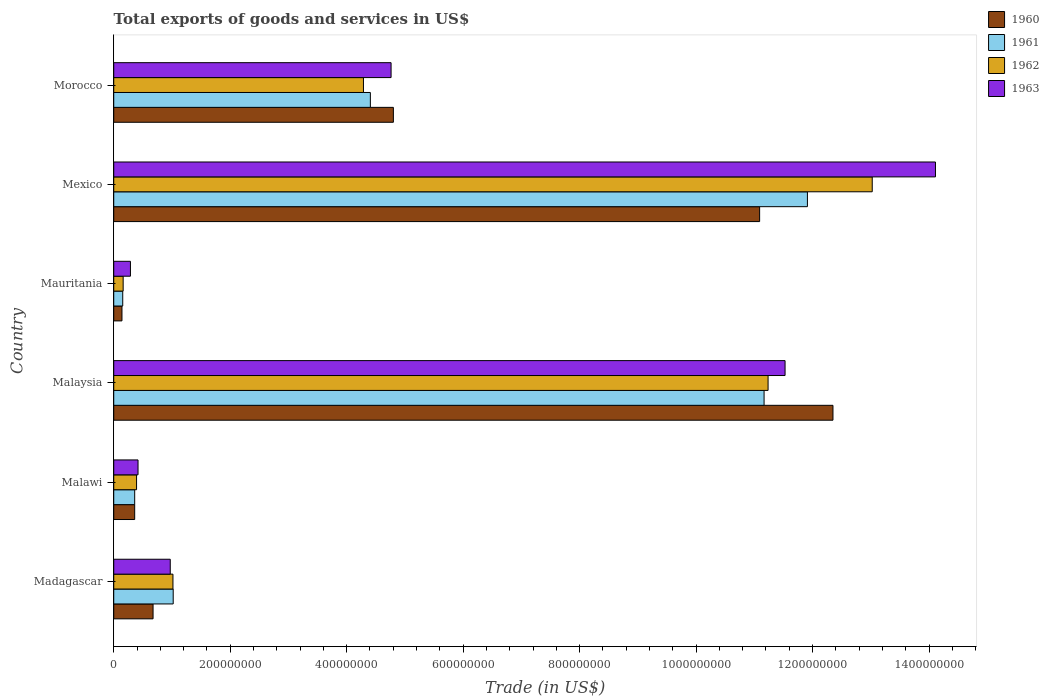How many groups of bars are there?
Make the answer very short. 6. Are the number of bars on each tick of the Y-axis equal?
Give a very brief answer. Yes. How many bars are there on the 1st tick from the top?
Provide a succinct answer. 4. How many bars are there on the 5th tick from the bottom?
Make the answer very short. 4. What is the label of the 3rd group of bars from the top?
Give a very brief answer. Mauritania. What is the total exports of goods and services in 1961 in Morocco?
Your answer should be very brief. 4.41e+08. Across all countries, what is the maximum total exports of goods and services in 1962?
Offer a very short reply. 1.30e+09. Across all countries, what is the minimum total exports of goods and services in 1962?
Ensure brevity in your answer.  1.62e+07. In which country was the total exports of goods and services in 1960 minimum?
Your answer should be compact. Mauritania. What is the total total exports of goods and services in 1963 in the graph?
Ensure brevity in your answer.  3.21e+09. What is the difference between the total exports of goods and services in 1960 in Malawi and that in Malaysia?
Offer a terse response. -1.20e+09. What is the difference between the total exports of goods and services in 1961 in Mauritania and the total exports of goods and services in 1960 in Mexico?
Give a very brief answer. -1.09e+09. What is the average total exports of goods and services in 1962 per country?
Keep it short and to the point. 5.02e+08. What is the difference between the total exports of goods and services in 1963 and total exports of goods and services in 1960 in Madagascar?
Your answer should be compact. 2.95e+07. What is the ratio of the total exports of goods and services in 1961 in Madagascar to that in Mauritania?
Provide a succinct answer. 6.61. Is the total exports of goods and services in 1963 in Malaysia less than that in Morocco?
Offer a terse response. No. Is the difference between the total exports of goods and services in 1963 in Malaysia and Mauritania greater than the difference between the total exports of goods and services in 1960 in Malaysia and Mauritania?
Provide a succinct answer. No. What is the difference between the highest and the second highest total exports of goods and services in 1962?
Keep it short and to the point. 1.79e+08. What is the difference between the highest and the lowest total exports of goods and services in 1960?
Your response must be concise. 1.22e+09. In how many countries, is the total exports of goods and services in 1960 greater than the average total exports of goods and services in 1960 taken over all countries?
Your answer should be very brief. 2. Is the sum of the total exports of goods and services in 1960 in Malawi and Mauritania greater than the maximum total exports of goods and services in 1962 across all countries?
Provide a succinct answer. No. What does the 3rd bar from the top in Morocco represents?
Keep it short and to the point. 1961. What does the 4th bar from the bottom in Malawi represents?
Offer a terse response. 1963. How many countries are there in the graph?
Offer a terse response. 6. Does the graph contain any zero values?
Your answer should be very brief. No. Does the graph contain grids?
Your answer should be compact. No. How many legend labels are there?
Offer a very short reply. 4. What is the title of the graph?
Provide a short and direct response. Total exports of goods and services in US$. What is the label or title of the X-axis?
Your response must be concise. Trade (in US$). What is the label or title of the Y-axis?
Offer a very short reply. Country. What is the Trade (in US$) of 1960 in Madagascar?
Your response must be concise. 6.75e+07. What is the Trade (in US$) of 1961 in Madagascar?
Offer a terse response. 1.02e+08. What is the Trade (in US$) in 1962 in Madagascar?
Your answer should be compact. 1.02e+08. What is the Trade (in US$) in 1963 in Madagascar?
Give a very brief answer. 9.70e+07. What is the Trade (in US$) of 1960 in Malawi?
Ensure brevity in your answer.  3.60e+07. What is the Trade (in US$) in 1961 in Malawi?
Your answer should be compact. 3.60e+07. What is the Trade (in US$) of 1962 in Malawi?
Your answer should be very brief. 3.92e+07. What is the Trade (in US$) of 1963 in Malawi?
Your response must be concise. 4.17e+07. What is the Trade (in US$) of 1960 in Malaysia?
Keep it short and to the point. 1.24e+09. What is the Trade (in US$) in 1961 in Malaysia?
Offer a very short reply. 1.12e+09. What is the Trade (in US$) of 1962 in Malaysia?
Your answer should be very brief. 1.12e+09. What is the Trade (in US$) of 1963 in Malaysia?
Provide a succinct answer. 1.15e+09. What is the Trade (in US$) in 1960 in Mauritania?
Ensure brevity in your answer.  1.41e+07. What is the Trade (in US$) in 1961 in Mauritania?
Ensure brevity in your answer.  1.54e+07. What is the Trade (in US$) of 1962 in Mauritania?
Your response must be concise. 1.62e+07. What is the Trade (in US$) of 1963 in Mauritania?
Offer a terse response. 2.87e+07. What is the Trade (in US$) in 1960 in Mexico?
Keep it short and to the point. 1.11e+09. What is the Trade (in US$) in 1961 in Mexico?
Your answer should be very brief. 1.19e+09. What is the Trade (in US$) of 1962 in Mexico?
Offer a terse response. 1.30e+09. What is the Trade (in US$) of 1963 in Mexico?
Keep it short and to the point. 1.41e+09. What is the Trade (in US$) in 1960 in Morocco?
Make the answer very short. 4.80e+08. What is the Trade (in US$) in 1961 in Morocco?
Your response must be concise. 4.41e+08. What is the Trade (in US$) in 1962 in Morocco?
Your answer should be very brief. 4.29e+08. What is the Trade (in US$) of 1963 in Morocco?
Your answer should be very brief. 4.76e+08. Across all countries, what is the maximum Trade (in US$) of 1960?
Your response must be concise. 1.24e+09. Across all countries, what is the maximum Trade (in US$) in 1961?
Provide a short and direct response. 1.19e+09. Across all countries, what is the maximum Trade (in US$) in 1962?
Give a very brief answer. 1.30e+09. Across all countries, what is the maximum Trade (in US$) in 1963?
Provide a succinct answer. 1.41e+09. Across all countries, what is the minimum Trade (in US$) of 1960?
Ensure brevity in your answer.  1.41e+07. Across all countries, what is the minimum Trade (in US$) in 1961?
Offer a terse response. 1.54e+07. Across all countries, what is the minimum Trade (in US$) of 1962?
Offer a terse response. 1.62e+07. Across all countries, what is the minimum Trade (in US$) in 1963?
Provide a short and direct response. 2.87e+07. What is the total Trade (in US$) in 1960 in the graph?
Offer a very short reply. 2.94e+09. What is the total Trade (in US$) in 1961 in the graph?
Provide a succinct answer. 2.90e+09. What is the total Trade (in US$) in 1962 in the graph?
Make the answer very short. 3.01e+09. What is the total Trade (in US$) in 1963 in the graph?
Make the answer very short. 3.21e+09. What is the difference between the Trade (in US$) of 1960 in Madagascar and that in Malawi?
Offer a very short reply. 3.15e+07. What is the difference between the Trade (in US$) in 1961 in Madagascar and that in Malawi?
Provide a succinct answer. 6.61e+07. What is the difference between the Trade (in US$) of 1962 in Madagascar and that in Malawi?
Your answer should be compact. 6.25e+07. What is the difference between the Trade (in US$) of 1963 in Madagascar and that in Malawi?
Your answer should be very brief. 5.53e+07. What is the difference between the Trade (in US$) of 1960 in Madagascar and that in Malaysia?
Offer a terse response. -1.17e+09. What is the difference between the Trade (in US$) in 1961 in Madagascar and that in Malaysia?
Make the answer very short. -1.01e+09. What is the difference between the Trade (in US$) of 1962 in Madagascar and that in Malaysia?
Your response must be concise. -1.02e+09. What is the difference between the Trade (in US$) in 1963 in Madagascar and that in Malaysia?
Give a very brief answer. -1.06e+09. What is the difference between the Trade (in US$) in 1960 in Madagascar and that in Mauritania?
Make the answer very short. 5.34e+07. What is the difference between the Trade (in US$) in 1961 in Madagascar and that in Mauritania?
Provide a short and direct response. 8.67e+07. What is the difference between the Trade (in US$) of 1962 in Madagascar and that in Mauritania?
Offer a very short reply. 8.55e+07. What is the difference between the Trade (in US$) of 1963 in Madagascar and that in Mauritania?
Make the answer very short. 6.84e+07. What is the difference between the Trade (in US$) in 1960 in Madagascar and that in Mexico?
Provide a short and direct response. -1.04e+09. What is the difference between the Trade (in US$) in 1961 in Madagascar and that in Mexico?
Provide a short and direct response. -1.09e+09. What is the difference between the Trade (in US$) in 1962 in Madagascar and that in Mexico?
Provide a short and direct response. -1.20e+09. What is the difference between the Trade (in US$) in 1963 in Madagascar and that in Mexico?
Provide a short and direct response. -1.31e+09. What is the difference between the Trade (in US$) of 1960 in Madagascar and that in Morocco?
Make the answer very short. -4.13e+08. What is the difference between the Trade (in US$) of 1961 in Madagascar and that in Morocco?
Offer a very short reply. -3.39e+08. What is the difference between the Trade (in US$) of 1962 in Madagascar and that in Morocco?
Provide a short and direct response. -3.27e+08. What is the difference between the Trade (in US$) in 1963 in Madagascar and that in Morocco?
Provide a succinct answer. -3.79e+08. What is the difference between the Trade (in US$) of 1960 in Malawi and that in Malaysia?
Offer a terse response. -1.20e+09. What is the difference between the Trade (in US$) in 1961 in Malawi and that in Malaysia?
Offer a terse response. -1.08e+09. What is the difference between the Trade (in US$) of 1962 in Malawi and that in Malaysia?
Provide a short and direct response. -1.08e+09. What is the difference between the Trade (in US$) of 1963 in Malawi and that in Malaysia?
Your response must be concise. -1.11e+09. What is the difference between the Trade (in US$) in 1960 in Malawi and that in Mauritania?
Your response must be concise. 2.18e+07. What is the difference between the Trade (in US$) of 1961 in Malawi and that in Mauritania?
Provide a short and direct response. 2.05e+07. What is the difference between the Trade (in US$) of 1962 in Malawi and that in Mauritania?
Your response must be concise. 2.30e+07. What is the difference between the Trade (in US$) in 1963 in Malawi and that in Mauritania?
Your answer should be compact. 1.30e+07. What is the difference between the Trade (in US$) of 1960 in Malawi and that in Mexico?
Your answer should be very brief. -1.07e+09. What is the difference between the Trade (in US$) of 1961 in Malawi and that in Mexico?
Offer a terse response. -1.16e+09. What is the difference between the Trade (in US$) in 1962 in Malawi and that in Mexico?
Ensure brevity in your answer.  -1.26e+09. What is the difference between the Trade (in US$) in 1963 in Malawi and that in Mexico?
Keep it short and to the point. -1.37e+09. What is the difference between the Trade (in US$) in 1960 in Malawi and that in Morocco?
Your response must be concise. -4.44e+08. What is the difference between the Trade (in US$) of 1961 in Malawi and that in Morocco?
Keep it short and to the point. -4.05e+08. What is the difference between the Trade (in US$) of 1962 in Malawi and that in Morocco?
Provide a succinct answer. -3.90e+08. What is the difference between the Trade (in US$) in 1963 in Malawi and that in Morocco?
Provide a succinct answer. -4.35e+08. What is the difference between the Trade (in US$) in 1960 in Malaysia and that in Mauritania?
Offer a very short reply. 1.22e+09. What is the difference between the Trade (in US$) in 1961 in Malaysia and that in Mauritania?
Your answer should be very brief. 1.10e+09. What is the difference between the Trade (in US$) in 1962 in Malaysia and that in Mauritania?
Provide a short and direct response. 1.11e+09. What is the difference between the Trade (in US$) in 1963 in Malaysia and that in Mauritania?
Your response must be concise. 1.12e+09. What is the difference between the Trade (in US$) of 1960 in Malaysia and that in Mexico?
Make the answer very short. 1.26e+08. What is the difference between the Trade (in US$) of 1961 in Malaysia and that in Mexico?
Offer a terse response. -7.44e+07. What is the difference between the Trade (in US$) in 1962 in Malaysia and that in Mexico?
Make the answer very short. -1.79e+08. What is the difference between the Trade (in US$) in 1963 in Malaysia and that in Mexico?
Your answer should be compact. -2.58e+08. What is the difference between the Trade (in US$) in 1960 in Malaysia and that in Morocco?
Keep it short and to the point. 7.55e+08. What is the difference between the Trade (in US$) in 1961 in Malaysia and that in Morocco?
Keep it short and to the point. 6.76e+08. What is the difference between the Trade (in US$) of 1962 in Malaysia and that in Morocco?
Keep it short and to the point. 6.95e+08. What is the difference between the Trade (in US$) of 1963 in Malaysia and that in Morocco?
Ensure brevity in your answer.  6.77e+08. What is the difference between the Trade (in US$) of 1960 in Mauritania and that in Mexico?
Your response must be concise. -1.09e+09. What is the difference between the Trade (in US$) in 1961 in Mauritania and that in Mexico?
Your answer should be very brief. -1.18e+09. What is the difference between the Trade (in US$) of 1962 in Mauritania and that in Mexico?
Your response must be concise. -1.29e+09. What is the difference between the Trade (in US$) in 1963 in Mauritania and that in Mexico?
Offer a very short reply. -1.38e+09. What is the difference between the Trade (in US$) in 1960 in Mauritania and that in Morocco?
Give a very brief answer. -4.66e+08. What is the difference between the Trade (in US$) in 1961 in Mauritania and that in Morocco?
Your response must be concise. -4.25e+08. What is the difference between the Trade (in US$) of 1962 in Mauritania and that in Morocco?
Your answer should be compact. -4.13e+08. What is the difference between the Trade (in US$) of 1963 in Mauritania and that in Morocco?
Your answer should be compact. -4.48e+08. What is the difference between the Trade (in US$) in 1960 in Mexico and that in Morocco?
Your answer should be compact. 6.29e+08. What is the difference between the Trade (in US$) in 1961 in Mexico and that in Morocco?
Keep it short and to the point. 7.51e+08. What is the difference between the Trade (in US$) in 1962 in Mexico and that in Morocco?
Offer a terse response. 8.74e+08. What is the difference between the Trade (in US$) of 1963 in Mexico and that in Morocco?
Offer a terse response. 9.35e+08. What is the difference between the Trade (in US$) in 1960 in Madagascar and the Trade (in US$) in 1961 in Malawi?
Your response must be concise. 3.15e+07. What is the difference between the Trade (in US$) of 1960 in Madagascar and the Trade (in US$) of 1962 in Malawi?
Your answer should be very brief. 2.83e+07. What is the difference between the Trade (in US$) in 1960 in Madagascar and the Trade (in US$) in 1963 in Malawi?
Your response must be concise. 2.58e+07. What is the difference between the Trade (in US$) of 1961 in Madagascar and the Trade (in US$) of 1962 in Malawi?
Offer a very short reply. 6.29e+07. What is the difference between the Trade (in US$) of 1961 in Madagascar and the Trade (in US$) of 1963 in Malawi?
Keep it short and to the point. 6.04e+07. What is the difference between the Trade (in US$) in 1962 in Madagascar and the Trade (in US$) in 1963 in Malawi?
Provide a succinct answer. 6.00e+07. What is the difference between the Trade (in US$) of 1960 in Madagascar and the Trade (in US$) of 1961 in Malaysia?
Make the answer very short. -1.05e+09. What is the difference between the Trade (in US$) of 1960 in Madagascar and the Trade (in US$) of 1962 in Malaysia?
Your response must be concise. -1.06e+09. What is the difference between the Trade (in US$) in 1960 in Madagascar and the Trade (in US$) in 1963 in Malaysia?
Your answer should be compact. -1.09e+09. What is the difference between the Trade (in US$) of 1961 in Madagascar and the Trade (in US$) of 1962 in Malaysia?
Offer a very short reply. -1.02e+09. What is the difference between the Trade (in US$) in 1961 in Madagascar and the Trade (in US$) in 1963 in Malaysia?
Your response must be concise. -1.05e+09. What is the difference between the Trade (in US$) of 1962 in Madagascar and the Trade (in US$) of 1963 in Malaysia?
Offer a very short reply. -1.05e+09. What is the difference between the Trade (in US$) in 1960 in Madagascar and the Trade (in US$) in 1961 in Mauritania?
Ensure brevity in your answer.  5.21e+07. What is the difference between the Trade (in US$) in 1960 in Madagascar and the Trade (in US$) in 1962 in Mauritania?
Keep it short and to the point. 5.14e+07. What is the difference between the Trade (in US$) in 1960 in Madagascar and the Trade (in US$) in 1963 in Mauritania?
Ensure brevity in your answer.  3.88e+07. What is the difference between the Trade (in US$) in 1961 in Madagascar and the Trade (in US$) in 1962 in Mauritania?
Make the answer very short. 8.60e+07. What is the difference between the Trade (in US$) in 1961 in Madagascar and the Trade (in US$) in 1963 in Mauritania?
Ensure brevity in your answer.  7.34e+07. What is the difference between the Trade (in US$) in 1962 in Madagascar and the Trade (in US$) in 1963 in Mauritania?
Keep it short and to the point. 7.30e+07. What is the difference between the Trade (in US$) in 1960 in Madagascar and the Trade (in US$) in 1961 in Mexico?
Offer a very short reply. -1.12e+09. What is the difference between the Trade (in US$) of 1960 in Madagascar and the Trade (in US$) of 1962 in Mexico?
Provide a short and direct response. -1.23e+09. What is the difference between the Trade (in US$) of 1960 in Madagascar and the Trade (in US$) of 1963 in Mexico?
Give a very brief answer. -1.34e+09. What is the difference between the Trade (in US$) of 1961 in Madagascar and the Trade (in US$) of 1962 in Mexico?
Ensure brevity in your answer.  -1.20e+09. What is the difference between the Trade (in US$) in 1961 in Madagascar and the Trade (in US$) in 1963 in Mexico?
Provide a succinct answer. -1.31e+09. What is the difference between the Trade (in US$) of 1962 in Madagascar and the Trade (in US$) of 1963 in Mexico?
Your answer should be very brief. -1.31e+09. What is the difference between the Trade (in US$) in 1960 in Madagascar and the Trade (in US$) in 1961 in Morocco?
Your response must be concise. -3.73e+08. What is the difference between the Trade (in US$) of 1960 in Madagascar and the Trade (in US$) of 1962 in Morocco?
Offer a very short reply. -3.61e+08. What is the difference between the Trade (in US$) of 1960 in Madagascar and the Trade (in US$) of 1963 in Morocco?
Provide a succinct answer. -4.09e+08. What is the difference between the Trade (in US$) of 1961 in Madagascar and the Trade (in US$) of 1962 in Morocco?
Make the answer very short. -3.27e+08. What is the difference between the Trade (in US$) of 1961 in Madagascar and the Trade (in US$) of 1963 in Morocco?
Provide a succinct answer. -3.74e+08. What is the difference between the Trade (in US$) of 1962 in Madagascar and the Trade (in US$) of 1963 in Morocco?
Offer a terse response. -3.75e+08. What is the difference between the Trade (in US$) of 1960 in Malawi and the Trade (in US$) of 1961 in Malaysia?
Your response must be concise. -1.08e+09. What is the difference between the Trade (in US$) in 1960 in Malawi and the Trade (in US$) in 1962 in Malaysia?
Your answer should be compact. -1.09e+09. What is the difference between the Trade (in US$) of 1960 in Malawi and the Trade (in US$) of 1963 in Malaysia?
Ensure brevity in your answer.  -1.12e+09. What is the difference between the Trade (in US$) in 1961 in Malawi and the Trade (in US$) in 1962 in Malaysia?
Provide a succinct answer. -1.09e+09. What is the difference between the Trade (in US$) in 1961 in Malawi and the Trade (in US$) in 1963 in Malaysia?
Your response must be concise. -1.12e+09. What is the difference between the Trade (in US$) in 1962 in Malawi and the Trade (in US$) in 1963 in Malaysia?
Your answer should be compact. -1.11e+09. What is the difference between the Trade (in US$) of 1960 in Malawi and the Trade (in US$) of 1961 in Mauritania?
Ensure brevity in your answer.  2.05e+07. What is the difference between the Trade (in US$) of 1960 in Malawi and the Trade (in US$) of 1962 in Mauritania?
Ensure brevity in your answer.  1.98e+07. What is the difference between the Trade (in US$) of 1960 in Malawi and the Trade (in US$) of 1963 in Mauritania?
Make the answer very short. 7.31e+06. What is the difference between the Trade (in US$) of 1961 in Malawi and the Trade (in US$) of 1962 in Mauritania?
Offer a very short reply. 1.98e+07. What is the difference between the Trade (in US$) in 1961 in Malawi and the Trade (in US$) in 1963 in Mauritania?
Your response must be concise. 7.31e+06. What is the difference between the Trade (in US$) of 1962 in Malawi and the Trade (in US$) of 1963 in Mauritania?
Keep it short and to the point. 1.05e+07. What is the difference between the Trade (in US$) of 1960 in Malawi and the Trade (in US$) of 1961 in Mexico?
Your answer should be very brief. -1.16e+09. What is the difference between the Trade (in US$) in 1960 in Malawi and the Trade (in US$) in 1962 in Mexico?
Provide a succinct answer. -1.27e+09. What is the difference between the Trade (in US$) of 1960 in Malawi and the Trade (in US$) of 1963 in Mexico?
Your response must be concise. -1.38e+09. What is the difference between the Trade (in US$) in 1961 in Malawi and the Trade (in US$) in 1962 in Mexico?
Provide a short and direct response. -1.27e+09. What is the difference between the Trade (in US$) in 1961 in Malawi and the Trade (in US$) in 1963 in Mexico?
Your response must be concise. -1.38e+09. What is the difference between the Trade (in US$) of 1962 in Malawi and the Trade (in US$) of 1963 in Mexico?
Make the answer very short. -1.37e+09. What is the difference between the Trade (in US$) of 1960 in Malawi and the Trade (in US$) of 1961 in Morocco?
Your answer should be very brief. -4.05e+08. What is the difference between the Trade (in US$) of 1960 in Malawi and the Trade (in US$) of 1962 in Morocco?
Offer a terse response. -3.93e+08. What is the difference between the Trade (in US$) of 1960 in Malawi and the Trade (in US$) of 1963 in Morocco?
Your answer should be very brief. -4.40e+08. What is the difference between the Trade (in US$) in 1961 in Malawi and the Trade (in US$) in 1962 in Morocco?
Make the answer very short. -3.93e+08. What is the difference between the Trade (in US$) in 1961 in Malawi and the Trade (in US$) in 1963 in Morocco?
Your response must be concise. -4.40e+08. What is the difference between the Trade (in US$) of 1962 in Malawi and the Trade (in US$) of 1963 in Morocco?
Keep it short and to the point. -4.37e+08. What is the difference between the Trade (in US$) of 1960 in Malaysia and the Trade (in US$) of 1961 in Mauritania?
Your answer should be very brief. 1.22e+09. What is the difference between the Trade (in US$) of 1960 in Malaysia and the Trade (in US$) of 1962 in Mauritania?
Offer a terse response. 1.22e+09. What is the difference between the Trade (in US$) in 1960 in Malaysia and the Trade (in US$) in 1963 in Mauritania?
Make the answer very short. 1.21e+09. What is the difference between the Trade (in US$) of 1961 in Malaysia and the Trade (in US$) of 1962 in Mauritania?
Ensure brevity in your answer.  1.10e+09. What is the difference between the Trade (in US$) of 1961 in Malaysia and the Trade (in US$) of 1963 in Mauritania?
Provide a succinct answer. 1.09e+09. What is the difference between the Trade (in US$) of 1962 in Malaysia and the Trade (in US$) of 1963 in Mauritania?
Keep it short and to the point. 1.09e+09. What is the difference between the Trade (in US$) of 1960 in Malaysia and the Trade (in US$) of 1961 in Mexico?
Offer a very short reply. 4.39e+07. What is the difference between the Trade (in US$) of 1960 in Malaysia and the Trade (in US$) of 1962 in Mexico?
Your answer should be compact. -6.74e+07. What is the difference between the Trade (in US$) in 1960 in Malaysia and the Trade (in US$) in 1963 in Mexico?
Give a very brief answer. -1.76e+08. What is the difference between the Trade (in US$) of 1961 in Malaysia and the Trade (in US$) of 1962 in Mexico?
Your response must be concise. -1.86e+08. What is the difference between the Trade (in US$) in 1961 in Malaysia and the Trade (in US$) in 1963 in Mexico?
Provide a succinct answer. -2.94e+08. What is the difference between the Trade (in US$) in 1962 in Malaysia and the Trade (in US$) in 1963 in Mexico?
Keep it short and to the point. -2.87e+08. What is the difference between the Trade (in US$) of 1960 in Malaysia and the Trade (in US$) of 1961 in Morocco?
Offer a terse response. 7.94e+08. What is the difference between the Trade (in US$) in 1960 in Malaysia and the Trade (in US$) in 1962 in Morocco?
Keep it short and to the point. 8.06e+08. What is the difference between the Trade (in US$) of 1960 in Malaysia and the Trade (in US$) of 1963 in Morocco?
Make the answer very short. 7.59e+08. What is the difference between the Trade (in US$) of 1961 in Malaysia and the Trade (in US$) of 1962 in Morocco?
Ensure brevity in your answer.  6.88e+08. What is the difference between the Trade (in US$) of 1961 in Malaysia and the Trade (in US$) of 1963 in Morocco?
Give a very brief answer. 6.41e+08. What is the difference between the Trade (in US$) in 1962 in Malaysia and the Trade (in US$) in 1963 in Morocco?
Ensure brevity in your answer.  6.47e+08. What is the difference between the Trade (in US$) in 1960 in Mauritania and the Trade (in US$) in 1961 in Mexico?
Provide a short and direct response. -1.18e+09. What is the difference between the Trade (in US$) of 1960 in Mauritania and the Trade (in US$) of 1962 in Mexico?
Offer a very short reply. -1.29e+09. What is the difference between the Trade (in US$) of 1960 in Mauritania and the Trade (in US$) of 1963 in Mexico?
Ensure brevity in your answer.  -1.40e+09. What is the difference between the Trade (in US$) of 1961 in Mauritania and the Trade (in US$) of 1962 in Mexico?
Offer a terse response. -1.29e+09. What is the difference between the Trade (in US$) of 1961 in Mauritania and the Trade (in US$) of 1963 in Mexico?
Your answer should be compact. -1.40e+09. What is the difference between the Trade (in US$) of 1962 in Mauritania and the Trade (in US$) of 1963 in Mexico?
Offer a terse response. -1.39e+09. What is the difference between the Trade (in US$) of 1960 in Mauritania and the Trade (in US$) of 1961 in Morocco?
Ensure brevity in your answer.  -4.27e+08. What is the difference between the Trade (in US$) in 1960 in Mauritania and the Trade (in US$) in 1962 in Morocco?
Provide a succinct answer. -4.15e+08. What is the difference between the Trade (in US$) in 1960 in Mauritania and the Trade (in US$) in 1963 in Morocco?
Keep it short and to the point. -4.62e+08. What is the difference between the Trade (in US$) in 1961 in Mauritania and the Trade (in US$) in 1962 in Morocco?
Provide a short and direct response. -4.13e+08. What is the difference between the Trade (in US$) of 1961 in Mauritania and the Trade (in US$) of 1963 in Morocco?
Give a very brief answer. -4.61e+08. What is the difference between the Trade (in US$) in 1962 in Mauritania and the Trade (in US$) in 1963 in Morocco?
Provide a short and direct response. -4.60e+08. What is the difference between the Trade (in US$) of 1960 in Mexico and the Trade (in US$) of 1961 in Morocco?
Keep it short and to the point. 6.68e+08. What is the difference between the Trade (in US$) of 1960 in Mexico and the Trade (in US$) of 1962 in Morocco?
Your response must be concise. 6.80e+08. What is the difference between the Trade (in US$) in 1960 in Mexico and the Trade (in US$) in 1963 in Morocco?
Offer a very short reply. 6.33e+08. What is the difference between the Trade (in US$) in 1961 in Mexico and the Trade (in US$) in 1962 in Morocco?
Offer a terse response. 7.62e+08. What is the difference between the Trade (in US$) in 1961 in Mexico and the Trade (in US$) in 1963 in Morocco?
Ensure brevity in your answer.  7.15e+08. What is the difference between the Trade (in US$) of 1962 in Mexico and the Trade (in US$) of 1963 in Morocco?
Give a very brief answer. 8.26e+08. What is the average Trade (in US$) of 1960 per country?
Make the answer very short. 4.90e+08. What is the average Trade (in US$) of 1961 per country?
Your answer should be very brief. 4.84e+08. What is the average Trade (in US$) in 1962 per country?
Give a very brief answer. 5.02e+08. What is the average Trade (in US$) in 1963 per country?
Your response must be concise. 5.35e+08. What is the difference between the Trade (in US$) in 1960 and Trade (in US$) in 1961 in Madagascar?
Provide a short and direct response. -3.46e+07. What is the difference between the Trade (in US$) of 1960 and Trade (in US$) of 1962 in Madagascar?
Offer a very short reply. -3.42e+07. What is the difference between the Trade (in US$) in 1960 and Trade (in US$) in 1963 in Madagascar?
Ensure brevity in your answer.  -2.95e+07. What is the difference between the Trade (in US$) in 1961 and Trade (in US$) in 1962 in Madagascar?
Provide a short and direct response. 4.22e+05. What is the difference between the Trade (in US$) of 1961 and Trade (in US$) of 1963 in Madagascar?
Offer a very short reply. 5.06e+06. What is the difference between the Trade (in US$) of 1962 and Trade (in US$) of 1963 in Madagascar?
Your answer should be very brief. 4.64e+06. What is the difference between the Trade (in US$) of 1960 and Trade (in US$) of 1962 in Malawi?
Make the answer very short. -3.22e+06. What is the difference between the Trade (in US$) of 1960 and Trade (in US$) of 1963 in Malawi?
Offer a terse response. -5.74e+06. What is the difference between the Trade (in US$) in 1961 and Trade (in US$) in 1962 in Malawi?
Your answer should be very brief. -3.22e+06. What is the difference between the Trade (in US$) in 1961 and Trade (in US$) in 1963 in Malawi?
Make the answer very short. -5.74e+06. What is the difference between the Trade (in US$) of 1962 and Trade (in US$) of 1963 in Malawi?
Your response must be concise. -2.52e+06. What is the difference between the Trade (in US$) in 1960 and Trade (in US$) in 1961 in Malaysia?
Keep it short and to the point. 1.18e+08. What is the difference between the Trade (in US$) of 1960 and Trade (in US$) of 1962 in Malaysia?
Offer a terse response. 1.11e+08. What is the difference between the Trade (in US$) of 1960 and Trade (in US$) of 1963 in Malaysia?
Offer a terse response. 8.23e+07. What is the difference between the Trade (in US$) in 1961 and Trade (in US$) in 1962 in Malaysia?
Your response must be concise. -6.88e+06. What is the difference between the Trade (in US$) in 1961 and Trade (in US$) in 1963 in Malaysia?
Provide a short and direct response. -3.60e+07. What is the difference between the Trade (in US$) of 1962 and Trade (in US$) of 1963 in Malaysia?
Make the answer very short. -2.92e+07. What is the difference between the Trade (in US$) of 1960 and Trade (in US$) of 1961 in Mauritania?
Offer a very short reply. -1.31e+06. What is the difference between the Trade (in US$) in 1960 and Trade (in US$) in 1962 in Mauritania?
Your response must be concise. -2.02e+06. What is the difference between the Trade (in US$) in 1960 and Trade (in US$) in 1963 in Mauritania?
Give a very brief answer. -1.45e+07. What is the difference between the Trade (in US$) of 1961 and Trade (in US$) of 1962 in Mauritania?
Offer a terse response. -7.07e+05. What is the difference between the Trade (in US$) in 1961 and Trade (in US$) in 1963 in Mauritania?
Provide a short and direct response. -1.32e+07. What is the difference between the Trade (in US$) of 1962 and Trade (in US$) of 1963 in Mauritania?
Make the answer very short. -1.25e+07. What is the difference between the Trade (in US$) of 1960 and Trade (in US$) of 1961 in Mexico?
Make the answer very short. -8.21e+07. What is the difference between the Trade (in US$) in 1960 and Trade (in US$) in 1962 in Mexico?
Keep it short and to the point. -1.93e+08. What is the difference between the Trade (in US$) in 1960 and Trade (in US$) in 1963 in Mexico?
Provide a succinct answer. -3.02e+08. What is the difference between the Trade (in US$) in 1961 and Trade (in US$) in 1962 in Mexico?
Offer a very short reply. -1.11e+08. What is the difference between the Trade (in US$) of 1961 and Trade (in US$) of 1963 in Mexico?
Your answer should be very brief. -2.20e+08. What is the difference between the Trade (in US$) in 1962 and Trade (in US$) in 1963 in Mexico?
Your answer should be very brief. -1.09e+08. What is the difference between the Trade (in US$) in 1960 and Trade (in US$) in 1961 in Morocco?
Provide a short and direct response. 3.95e+07. What is the difference between the Trade (in US$) in 1960 and Trade (in US$) in 1962 in Morocco?
Ensure brevity in your answer.  5.14e+07. What is the difference between the Trade (in US$) in 1960 and Trade (in US$) in 1963 in Morocco?
Provide a succinct answer. 3.95e+06. What is the difference between the Trade (in US$) in 1961 and Trade (in US$) in 1962 in Morocco?
Offer a terse response. 1.19e+07. What is the difference between the Trade (in US$) in 1961 and Trade (in US$) in 1963 in Morocco?
Make the answer very short. -3.56e+07. What is the difference between the Trade (in US$) of 1962 and Trade (in US$) of 1963 in Morocco?
Keep it short and to the point. -4.74e+07. What is the ratio of the Trade (in US$) of 1960 in Madagascar to that in Malawi?
Provide a succinct answer. 1.88. What is the ratio of the Trade (in US$) in 1961 in Madagascar to that in Malawi?
Make the answer very short. 2.84. What is the ratio of the Trade (in US$) in 1962 in Madagascar to that in Malawi?
Your answer should be compact. 2.59. What is the ratio of the Trade (in US$) in 1963 in Madagascar to that in Malawi?
Your answer should be very brief. 2.33. What is the ratio of the Trade (in US$) in 1960 in Madagascar to that in Malaysia?
Your response must be concise. 0.05. What is the ratio of the Trade (in US$) in 1961 in Madagascar to that in Malaysia?
Provide a succinct answer. 0.09. What is the ratio of the Trade (in US$) of 1962 in Madagascar to that in Malaysia?
Keep it short and to the point. 0.09. What is the ratio of the Trade (in US$) in 1963 in Madagascar to that in Malaysia?
Your answer should be very brief. 0.08. What is the ratio of the Trade (in US$) in 1960 in Madagascar to that in Mauritania?
Make the answer very short. 4.78. What is the ratio of the Trade (in US$) of 1961 in Madagascar to that in Mauritania?
Make the answer very short. 6.61. What is the ratio of the Trade (in US$) in 1962 in Madagascar to that in Mauritania?
Give a very brief answer. 6.29. What is the ratio of the Trade (in US$) of 1963 in Madagascar to that in Mauritania?
Provide a succinct answer. 3.38. What is the ratio of the Trade (in US$) in 1960 in Madagascar to that in Mexico?
Your response must be concise. 0.06. What is the ratio of the Trade (in US$) of 1961 in Madagascar to that in Mexico?
Offer a very short reply. 0.09. What is the ratio of the Trade (in US$) in 1962 in Madagascar to that in Mexico?
Give a very brief answer. 0.08. What is the ratio of the Trade (in US$) of 1963 in Madagascar to that in Mexico?
Offer a very short reply. 0.07. What is the ratio of the Trade (in US$) in 1960 in Madagascar to that in Morocco?
Offer a very short reply. 0.14. What is the ratio of the Trade (in US$) in 1961 in Madagascar to that in Morocco?
Offer a terse response. 0.23. What is the ratio of the Trade (in US$) in 1962 in Madagascar to that in Morocco?
Provide a short and direct response. 0.24. What is the ratio of the Trade (in US$) of 1963 in Madagascar to that in Morocco?
Give a very brief answer. 0.2. What is the ratio of the Trade (in US$) in 1960 in Malawi to that in Malaysia?
Make the answer very short. 0.03. What is the ratio of the Trade (in US$) of 1961 in Malawi to that in Malaysia?
Provide a short and direct response. 0.03. What is the ratio of the Trade (in US$) of 1962 in Malawi to that in Malaysia?
Offer a terse response. 0.03. What is the ratio of the Trade (in US$) of 1963 in Malawi to that in Malaysia?
Provide a succinct answer. 0.04. What is the ratio of the Trade (in US$) of 1960 in Malawi to that in Mauritania?
Your answer should be very brief. 2.55. What is the ratio of the Trade (in US$) of 1961 in Malawi to that in Mauritania?
Your answer should be compact. 2.33. What is the ratio of the Trade (in US$) in 1962 in Malawi to that in Mauritania?
Offer a very short reply. 2.43. What is the ratio of the Trade (in US$) of 1963 in Malawi to that in Mauritania?
Provide a short and direct response. 1.45. What is the ratio of the Trade (in US$) of 1960 in Malawi to that in Mexico?
Keep it short and to the point. 0.03. What is the ratio of the Trade (in US$) in 1961 in Malawi to that in Mexico?
Make the answer very short. 0.03. What is the ratio of the Trade (in US$) in 1962 in Malawi to that in Mexico?
Ensure brevity in your answer.  0.03. What is the ratio of the Trade (in US$) in 1963 in Malawi to that in Mexico?
Your answer should be very brief. 0.03. What is the ratio of the Trade (in US$) of 1960 in Malawi to that in Morocco?
Keep it short and to the point. 0.07. What is the ratio of the Trade (in US$) in 1961 in Malawi to that in Morocco?
Provide a short and direct response. 0.08. What is the ratio of the Trade (in US$) of 1962 in Malawi to that in Morocco?
Your answer should be very brief. 0.09. What is the ratio of the Trade (in US$) in 1963 in Malawi to that in Morocco?
Make the answer very short. 0.09. What is the ratio of the Trade (in US$) of 1960 in Malaysia to that in Mauritania?
Give a very brief answer. 87.37. What is the ratio of the Trade (in US$) of 1961 in Malaysia to that in Mauritania?
Keep it short and to the point. 72.29. What is the ratio of the Trade (in US$) in 1962 in Malaysia to that in Mauritania?
Your answer should be very brief. 69.56. What is the ratio of the Trade (in US$) in 1963 in Malaysia to that in Mauritania?
Provide a succinct answer. 40.2. What is the ratio of the Trade (in US$) of 1960 in Malaysia to that in Mexico?
Your response must be concise. 1.11. What is the ratio of the Trade (in US$) of 1961 in Malaysia to that in Mexico?
Keep it short and to the point. 0.94. What is the ratio of the Trade (in US$) in 1962 in Malaysia to that in Mexico?
Your answer should be very brief. 0.86. What is the ratio of the Trade (in US$) in 1963 in Malaysia to that in Mexico?
Keep it short and to the point. 0.82. What is the ratio of the Trade (in US$) in 1960 in Malaysia to that in Morocco?
Provide a short and direct response. 2.57. What is the ratio of the Trade (in US$) of 1961 in Malaysia to that in Morocco?
Your answer should be very brief. 2.53. What is the ratio of the Trade (in US$) in 1962 in Malaysia to that in Morocco?
Your answer should be compact. 2.62. What is the ratio of the Trade (in US$) in 1963 in Malaysia to that in Morocco?
Keep it short and to the point. 2.42. What is the ratio of the Trade (in US$) in 1960 in Mauritania to that in Mexico?
Ensure brevity in your answer.  0.01. What is the ratio of the Trade (in US$) in 1961 in Mauritania to that in Mexico?
Give a very brief answer. 0.01. What is the ratio of the Trade (in US$) in 1962 in Mauritania to that in Mexico?
Give a very brief answer. 0.01. What is the ratio of the Trade (in US$) of 1963 in Mauritania to that in Mexico?
Give a very brief answer. 0.02. What is the ratio of the Trade (in US$) of 1960 in Mauritania to that in Morocco?
Ensure brevity in your answer.  0.03. What is the ratio of the Trade (in US$) in 1961 in Mauritania to that in Morocco?
Provide a short and direct response. 0.04. What is the ratio of the Trade (in US$) in 1962 in Mauritania to that in Morocco?
Ensure brevity in your answer.  0.04. What is the ratio of the Trade (in US$) in 1963 in Mauritania to that in Morocco?
Your response must be concise. 0.06. What is the ratio of the Trade (in US$) of 1960 in Mexico to that in Morocco?
Your answer should be very brief. 2.31. What is the ratio of the Trade (in US$) of 1961 in Mexico to that in Morocco?
Give a very brief answer. 2.7. What is the ratio of the Trade (in US$) in 1962 in Mexico to that in Morocco?
Ensure brevity in your answer.  3.04. What is the ratio of the Trade (in US$) of 1963 in Mexico to that in Morocco?
Provide a short and direct response. 2.96. What is the difference between the highest and the second highest Trade (in US$) of 1960?
Your answer should be very brief. 1.26e+08. What is the difference between the highest and the second highest Trade (in US$) of 1961?
Ensure brevity in your answer.  7.44e+07. What is the difference between the highest and the second highest Trade (in US$) of 1962?
Offer a very short reply. 1.79e+08. What is the difference between the highest and the second highest Trade (in US$) in 1963?
Provide a succinct answer. 2.58e+08. What is the difference between the highest and the lowest Trade (in US$) in 1960?
Give a very brief answer. 1.22e+09. What is the difference between the highest and the lowest Trade (in US$) in 1961?
Ensure brevity in your answer.  1.18e+09. What is the difference between the highest and the lowest Trade (in US$) in 1962?
Your answer should be compact. 1.29e+09. What is the difference between the highest and the lowest Trade (in US$) in 1963?
Your answer should be compact. 1.38e+09. 